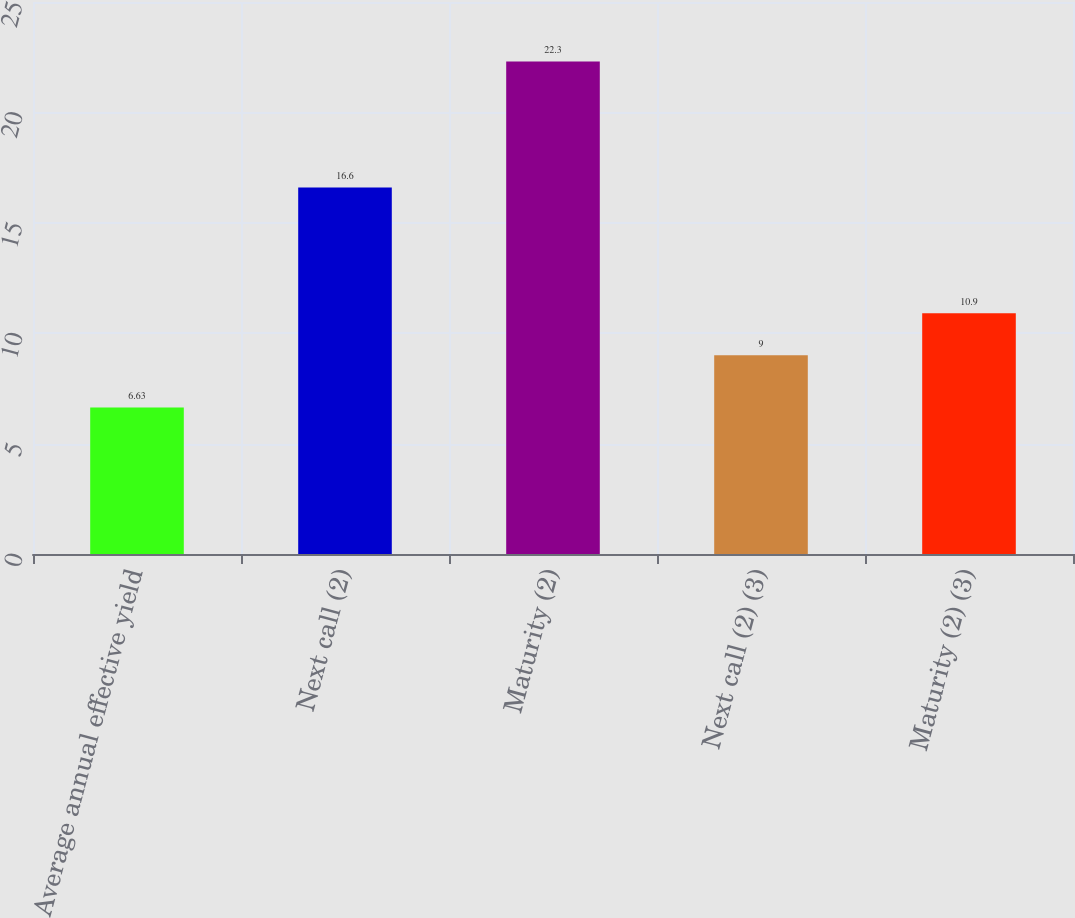<chart> <loc_0><loc_0><loc_500><loc_500><bar_chart><fcel>Average annual effective yield<fcel>Next call (2)<fcel>Maturity (2)<fcel>Next call (2) (3)<fcel>Maturity (2) (3)<nl><fcel>6.63<fcel>16.6<fcel>22.3<fcel>9<fcel>10.9<nl></chart> 